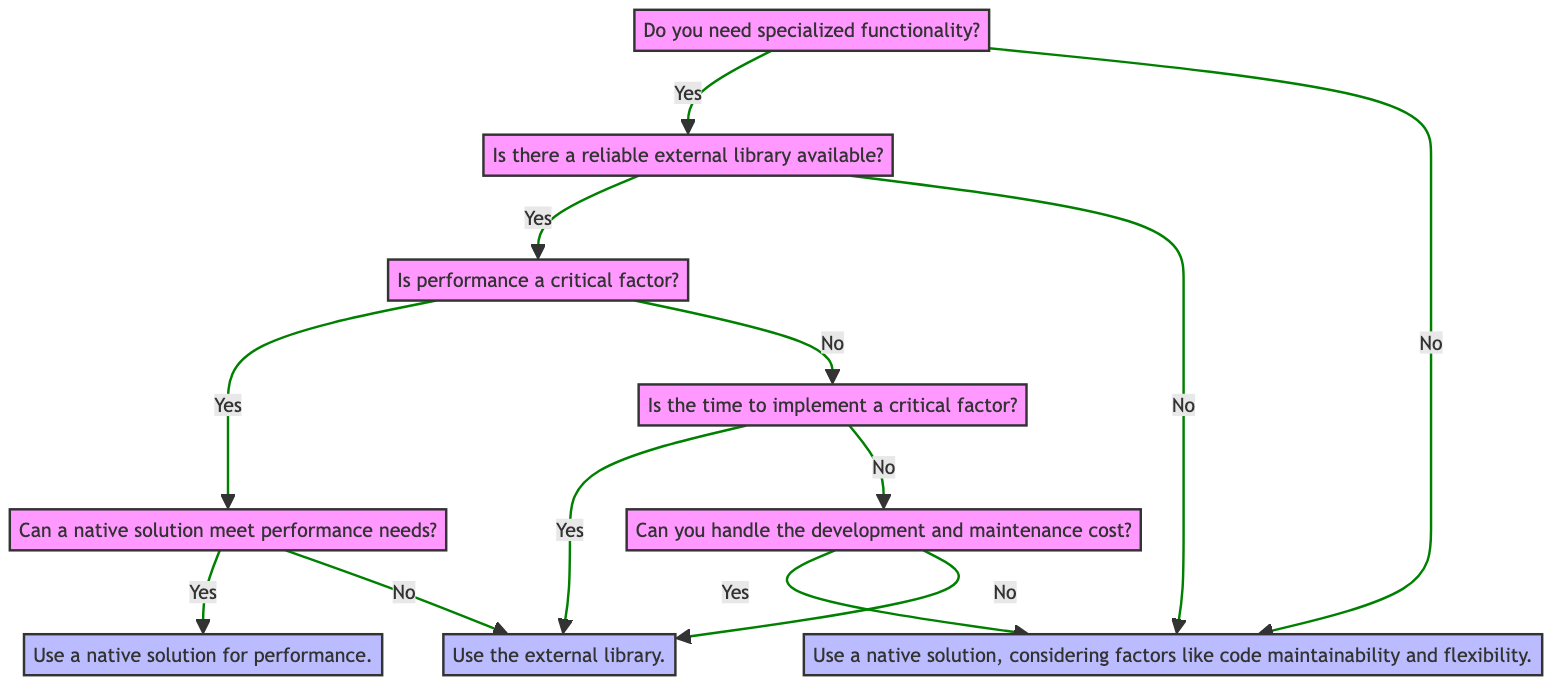What is the starting question of the decision tree? The decision tree starts with the question, "Do you need specialized functionality?" which is the first node.
Answer: Do you need specialized functionality? How many nodes are present in the decision tree? The decision tree has a total of 9 nodes, including both questions and decisions.
Answer: 9 What is the decision if there is no reliable external library? If there is no reliable external library, the decision is to use a native solution, considering factors like code maintainability and flexibility.
Answer: Use a native solution, considering factors like code maintainability and flexibility What happens if performance is a critical factor and a native solution cannot meet performance needs? If performance is a critical factor and a native solution cannot meet performance needs, the decision is to opt for the external library.
Answer: Opt for the external library If the time to implement is a critical factor, what is the decision? If the time to implement is a critical factor, the decision is to opt for the external library.
Answer: Opt for the external library What do you conclude if you can handle the development and maintenance cost? If you can handle the development and maintenance cost, the decision is to use a native solution, considering factors like code maintainability and flexibility.
Answer: Use a native solution, considering factors like code maintainability and flexibility What is the relationship between the nodes "performanceFactor" and "evaluateNativePerformance"? The "performanceFactor" node leads to the "evaluateNativePerformance" node if the answer is yes, indicating a direct connection where performance consideration influences native performance evaluation.
Answer: Direct connection What is the final decision if specialized functionality is needed and no reliable library is found? The final decision would be to use a native solution, considering factors like code maintainability and flexibility, as per the decision path from specialized functionality.
Answer: Use a native solution, considering factors like code maintainability and flexibility 